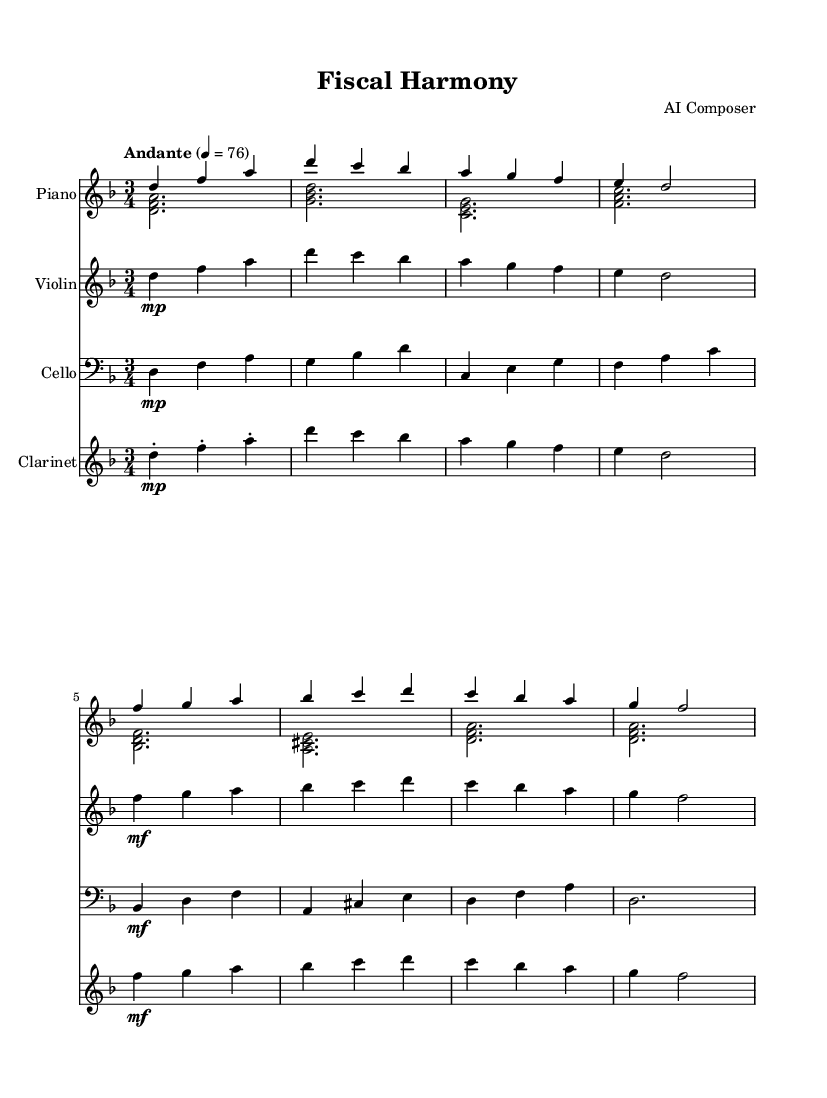What is the key signature of this music? The key signature is D minor, which has one flat (B flat). You can identify the key signature by looking at the beginning of the staff, where it shows one flat.
Answer: D minor What is the time signature of this piece? The time signature is 3/4, which means there are three beats in a measure and the quarter note gets the beat. You can find the time signature at the beginning next to the key signature.
Answer: 3/4 What is the tempo marking for this piece? The tempo marking indicates "Andante," which means a moderately slow tempo. This is shown at the beginning of the score with the word "Andante."
Answer: Andante How many instruments are featured in this composition? The score features four instruments: Piano, Violin, Cello, and Clarinet, which are each represented by their own staff. The layout provides clarity on the instrumentation used.
Answer: Four What dynamic marking is indicated for the violin in the second measure? The dynamic marking for the violin in the second measure is "mp," which stands for mezzo-piano, indicating a moderately soft volume. This marking is placed before the notes in the second measure of the violin part.
Answer: mp Which voice plays the left hand in the score? The left hand part is played by the "voiceTwo" in the piano staff as indicated in the notation where the parts are labeled. The left hand is specified directly in the score layout.
Answer: voiceTwo What type of musical piece is "Fiscal Harmony"? "Fiscal Harmony" is a contemporary classical piece, as indicated by its style and structure, featuring a mix of instruments typically found in classical compositions. This understanding comes from the overall characteristics of the score and the nature of its composition.
Answer: Contemporary classical 